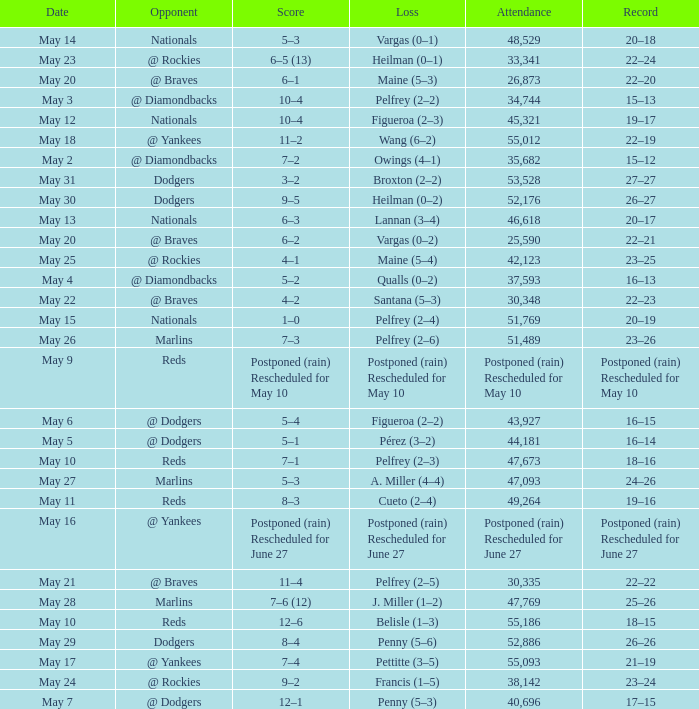Loss of postponed (rain) rescheduled for may 10 had what record? Postponed (rain) Rescheduled for May 10. 